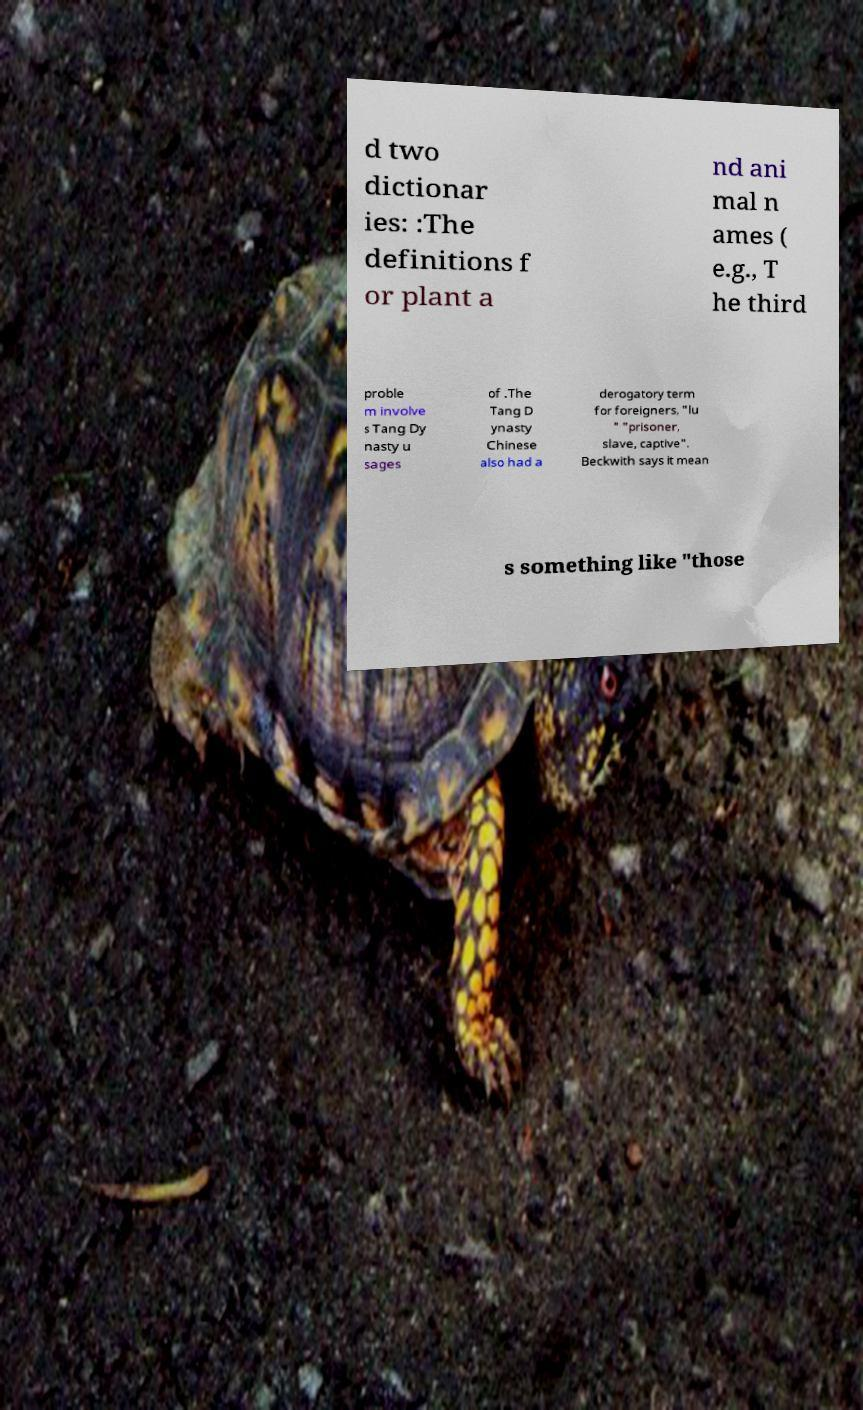There's text embedded in this image that I need extracted. Can you transcribe it verbatim? d two dictionar ies: :The definitions f or plant a nd ani mal n ames ( e.g., T he third proble m involve s Tang Dy nasty u sages of .The Tang D ynasty Chinese also had a derogatory term for foreigners, "lu " "prisoner, slave, captive". Beckwith says it mean s something like "those 